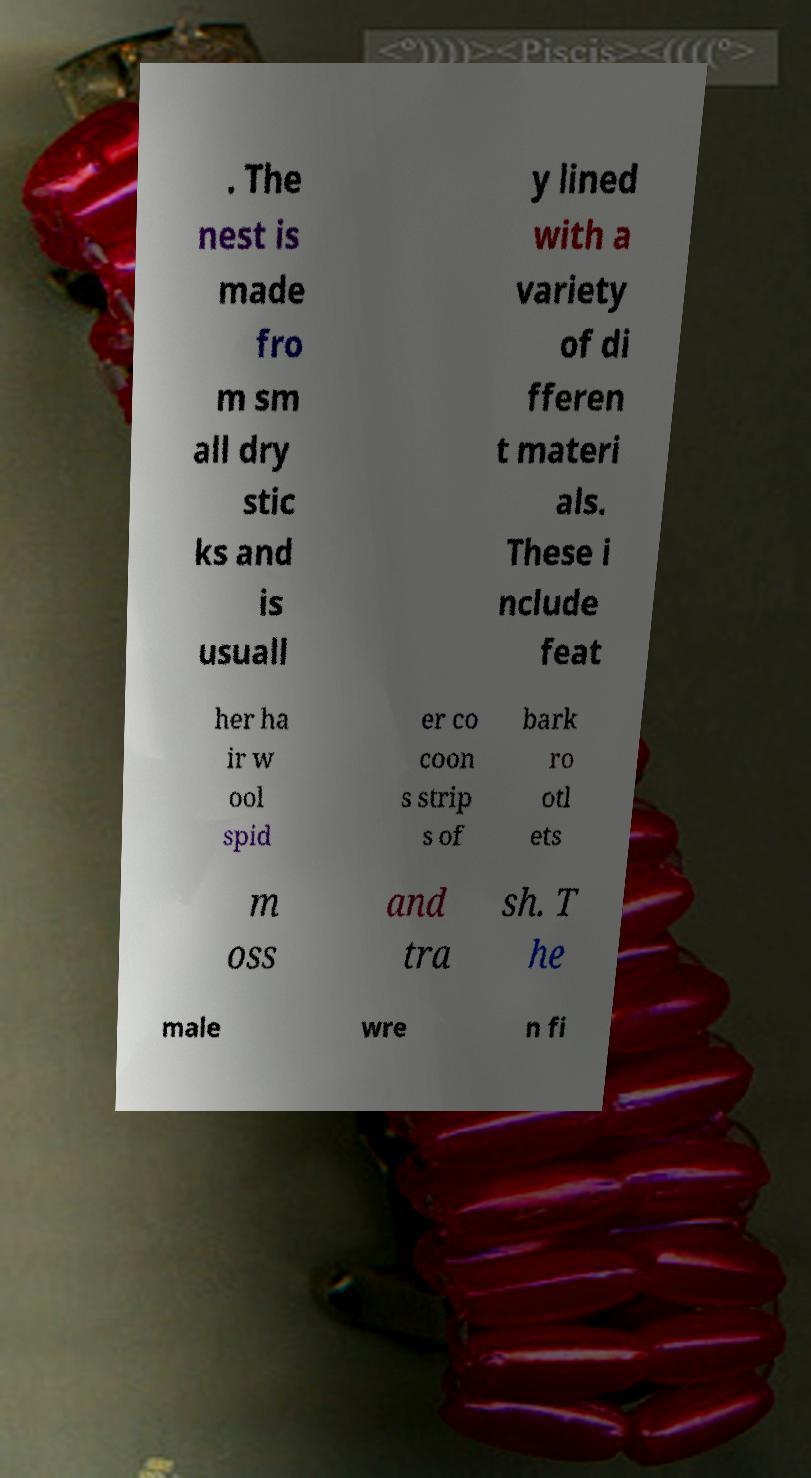Can you accurately transcribe the text from the provided image for me? . The nest is made fro m sm all dry stic ks and is usuall y lined with a variety of di fferen t materi als. These i nclude feat her ha ir w ool spid er co coon s strip s of bark ro otl ets m oss and tra sh. T he male wre n fi 